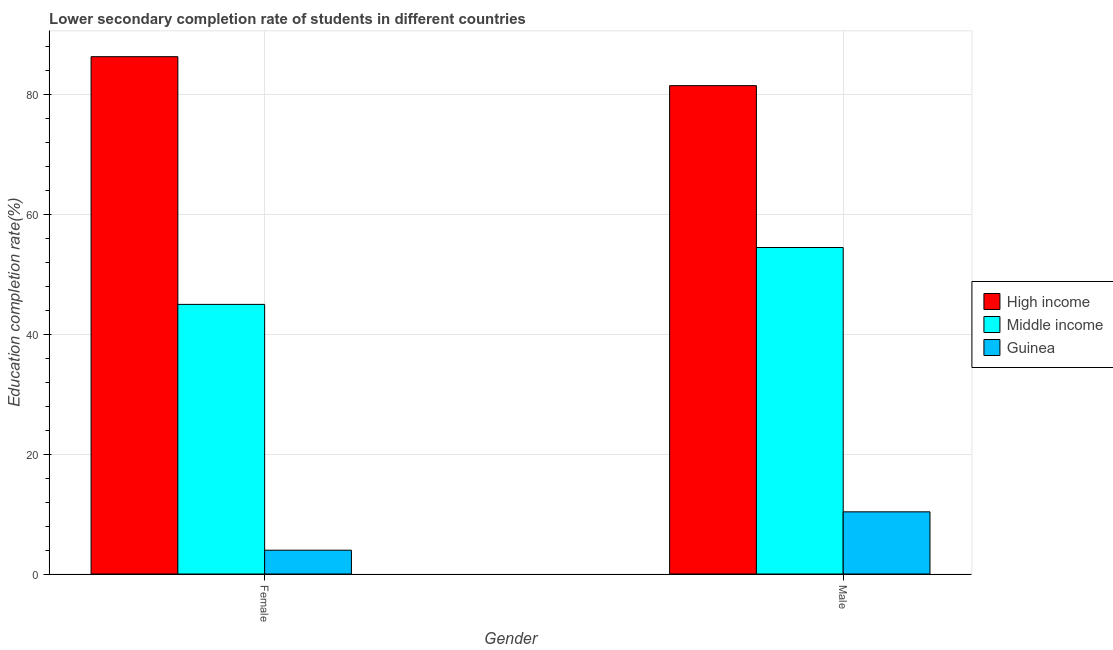How many groups of bars are there?
Your answer should be compact. 2. How many bars are there on the 2nd tick from the left?
Ensure brevity in your answer.  3. How many bars are there on the 1st tick from the right?
Your answer should be very brief. 3. What is the label of the 1st group of bars from the left?
Give a very brief answer. Female. What is the education completion rate of male students in High income?
Your response must be concise. 81.51. Across all countries, what is the maximum education completion rate of male students?
Make the answer very short. 81.51. Across all countries, what is the minimum education completion rate of female students?
Your answer should be compact. 3.97. In which country was the education completion rate of male students minimum?
Your answer should be very brief. Guinea. What is the total education completion rate of female students in the graph?
Provide a succinct answer. 135.31. What is the difference between the education completion rate of male students in Middle income and that in Guinea?
Provide a succinct answer. 44.12. What is the difference between the education completion rate of female students in Guinea and the education completion rate of male students in Middle income?
Offer a terse response. -50.52. What is the average education completion rate of female students per country?
Offer a terse response. 45.1. What is the difference between the education completion rate of female students and education completion rate of male students in Middle income?
Make the answer very short. -9.49. What is the ratio of the education completion rate of male students in Middle income to that in Guinea?
Your response must be concise. 5.25. In how many countries, is the education completion rate of female students greater than the average education completion rate of female students taken over all countries?
Ensure brevity in your answer.  1. What does the 2nd bar from the right in Female represents?
Your answer should be compact. Middle income. How many bars are there?
Ensure brevity in your answer.  6. How many countries are there in the graph?
Your answer should be very brief. 3. What is the difference between two consecutive major ticks on the Y-axis?
Your answer should be very brief. 20. Does the graph contain grids?
Keep it short and to the point. Yes. What is the title of the graph?
Offer a terse response. Lower secondary completion rate of students in different countries. What is the label or title of the Y-axis?
Your answer should be compact. Education completion rate(%). What is the Education completion rate(%) in High income in Female?
Provide a succinct answer. 86.34. What is the Education completion rate(%) of Middle income in Female?
Ensure brevity in your answer.  45. What is the Education completion rate(%) in Guinea in Female?
Your answer should be very brief. 3.97. What is the Education completion rate(%) in High income in Male?
Offer a terse response. 81.51. What is the Education completion rate(%) in Middle income in Male?
Your answer should be compact. 54.49. What is the Education completion rate(%) of Guinea in Male?
Provide a succinct answer. 10.37. Across all Gender, what is the maximum Education completion rate(%) in High income?
Keep it short and to the point. 86.34. Across all Gender, what is the maximum Education completion rate(%) of Middle income?
Your response must be concise. 54.49. Across all Gender, what is the maximum Education completion rate(%) of Guinea?
Provide a succinct answer. 10.37. Across all Gender, what is the minimum Education completion rate(%) in High income?
Offer a very short reply. 81.51. Across all Gender, what is the minimum Education completion rate(%) of Middle income?
Your response must be concise. 45. Across all Gender, what is the minimum Education completion rate(%) of Guinea?
Give a very brief answer. 3.97. What is the total Education completion rate(%) of High income in the graph?
Offer a terse response. 167.84. What is the total Education completion rate(%) in Middle income in the graph?
Offer a terse response. 99.49. What is the total Education completion rate(%) in Guinea in the graph?
Your answer should be compact. 14.35. What is the difference between the Education completion rate(%) in High income in Female and that in Male?
Ensure brevity in your answer.  4.83. What is the difference between the Education completion rate(%) of Middle income in Female and that in Male?
Ensure brevity in your answer.  -9.49. What is the difference between the Education completion rate(%) in Guinea in Female and that in Male?
Offer a very short reply. -6.4. What is the difference between the Education completion rate(%) of High income in Female and the Education completion rate(%) of Middle income in Male?
Keep it short and to the point. 31.85. What is the difference between the Education completion rate(%) of High income in Female and the Education completion rate(%) of Guinea in Male?
Make the answer very short. 75.96. What is the difference between the Education completion rate(%) in Middle income in Female and the Education completion rate(%) in Guinea in Male?
Your answer should be compact. 34.62. What is the average Education completion rate(%) in High income per Gender?
Give a very brief answer. 83.92. What is the average Education completion rate(%) in Middle income per Gender?
Ensure brevity in your answer.  49.75. What is the average Education completion rate(%) in Guinea per Gender?
Provide a succinct answer. 7.17. What is the difference between the Education completion rate(%) of High income and Education completion rate(%) of Middle income in Female?
Offer a terse response. 41.34. What is the difference between the Education completion rate(%) in High income and Education completion rate(%) in Guinea in Female?
Your answer should be compact. 82.37. What is the difference between the Education completion rate(%) of Middle income and Education completion rate(%) of Guinea in Female?
Make the answer very short. 41.03. What is the difference between the Education completion rate(%) in High income and Education completion rate(%) in Middle income in Male?
Keep it short and to the point. 27.01. What is the difference between the Education completion rate(%) of High income and Education completion rate(%) of Guinea in Male?
Keep it short and to the point. 71.13. What is the difference between the Education completion rate(%) of Middle income and Education completion rate(%) of Guinea in Male?
Ensure brevity in your answer.  44.12. What is the ratio of the Education completion rate(%) in High income in Female to that in Male?
Your answer should be very brief. 1.06. What is the ratio of the Education completion rate(%) of Middle income in Female to that in Male?
Ensure brevity in your answer.  0.83. What is the ratio of the Education completion rate(%) of Guinea in Female to that in Male?
Your answer should be very brief. 0.38. What is the difference between the highest and the second highest Education completion rate(%) of High income?
Make the answer very short. 4.83. What is the difference between the highest and the second highest Education completion rate(%) of Middle income?
Keep it short and to the point. 9.49. What is the difference between the highest and the second highest Education completion rate(%) in Guinea?
Offer a terse response. 6.4. What is the difference between the highest and the lowest Education completion rate(%) of High income?
Your answer should be very brief. 4.83. What is the difference between the highest and the lowest Education completion rate(%) in Middle income?
Your answer should be compact. 9.49. What is the difference between the highest and the lowest Education completion rate(%) in Guinea?
Make the answer very short. 6.4. 